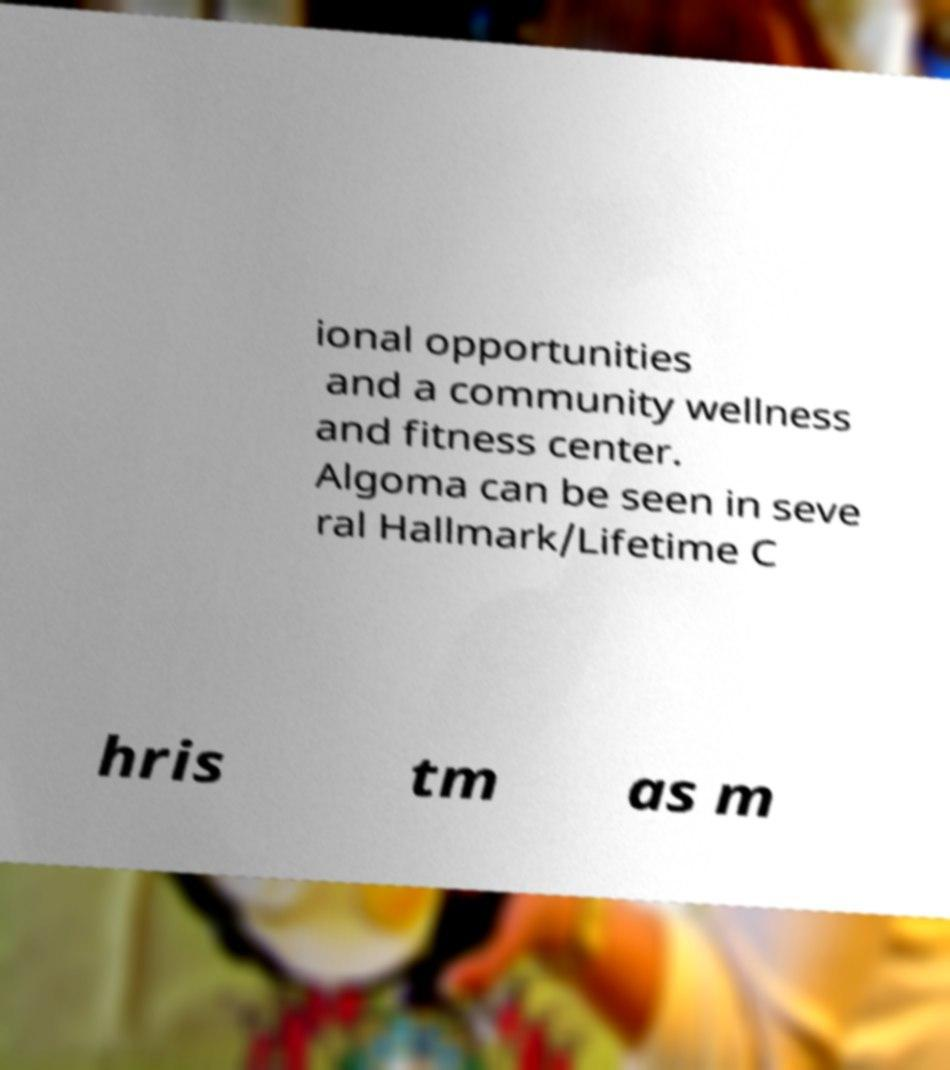For documentation purposes, I need the text within this image transcribed. Could you provide that? ional opportunities and a community wellness and fitness center. Algoma can be seen in seve ral Hallmark/Lifetime C hris tm as m 